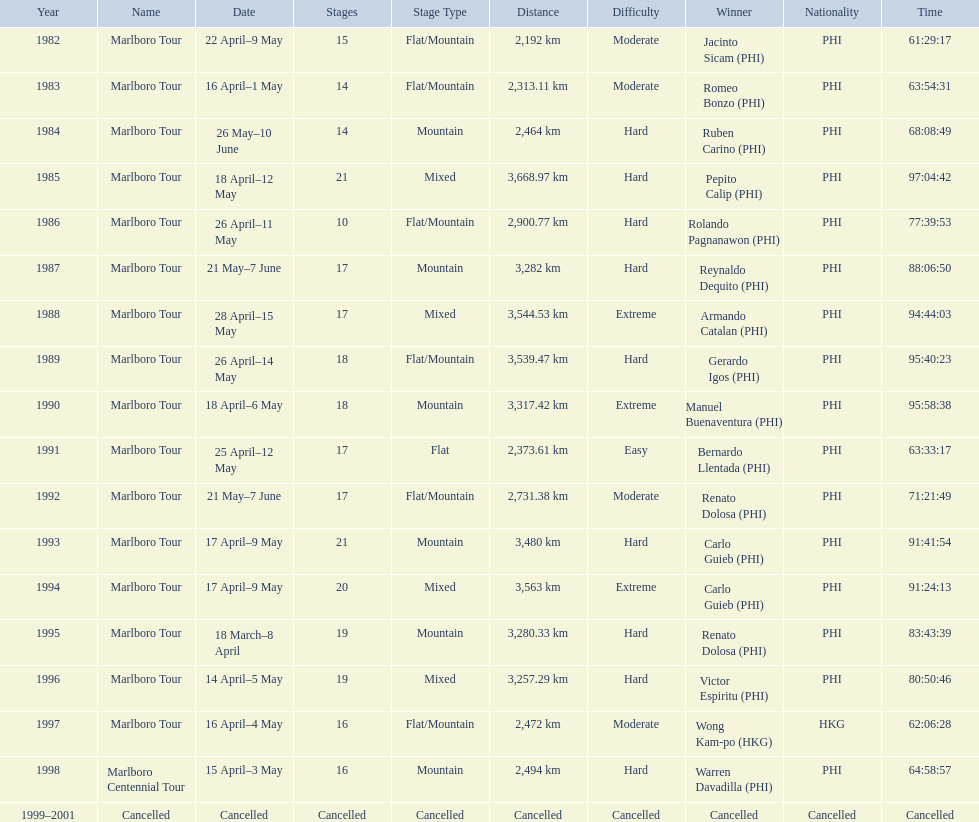Who were all of the winners? Jacinto Sicam (PHI), Romeo Bonzo (PHI), Ruben Carino (PHI), Pepito Calip (PHI), Rolando Pagnanawon (PHI), Reynaldo Dequito (PHI), Armando Catalan (PHI), Gerardo Igos (PHI), Manuel Buenaventura (PHI), Bernardo Llentada (PHI), Renato Dolosa (PHI), Carlo Guieb (PHI), Carlo Guieb (PHI), Renato Dolosa (PHI), Victor Espiritu (PHI), Wong Kam-po (HKG), Warren Davadilla (PHI), Cancelled. When did they compete? 1982, 1983, 1984, 1985, 1986, 1987, 1988, 1989, 1990, 1991, 1992, 1993, 1994, 1995, 1996, 1997, 1998, 1999–2001. What were their finishing times? 61:29:17, 63:54:31, 68:08:49, 97:04:42, 77:39:53, 88:06:50, 94:44:03, 95:40:23, 95:58:38, 63:33:17, 71:21:49, 91:41:54, 91:24:13, 83:43:39, 80:50:46, 62:06:28, 64:58:57, Cancelled. And who won during 1998? Warren Davadilla (PHI). What was his time? 64:58:57. 